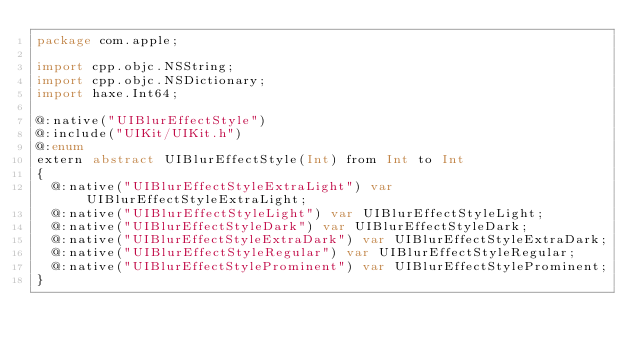<code> <loc_0><loc_0><loc_500><loc_500><_Haxe_>package com.apple;

import cpp.objc.NSString;
import cpp.objc.NSDictionary;
import haxe.Int64;

@:native("UIBlurEffectStyle")
@:include("UIKit/UIKit.h")
@:enum
extern abstract UIBlurEffectStyle(Int) from Int to Int
{
  @:native("UIBlurEffectStyleExtraLight") var UIBlurEffectStyleExtraLight;
  @:native("UIBlurEffectStyleLight") var UIBlurEffectStyleLight;
  @:native("UIBlurEffectStyleDark") var UIBlurEffectStyleDark;
  @:native("UIBlurEffectStyleExtraDark") var UIBlurEffectStyleExtraDark;
  @:native("UIBlurEffectStyleRegular") var UIBlurEffectStyleRegular;
  @:native("UIBlurEffectStyleProminent") var UIBlurEffectStyleProminent;
}
</code> 